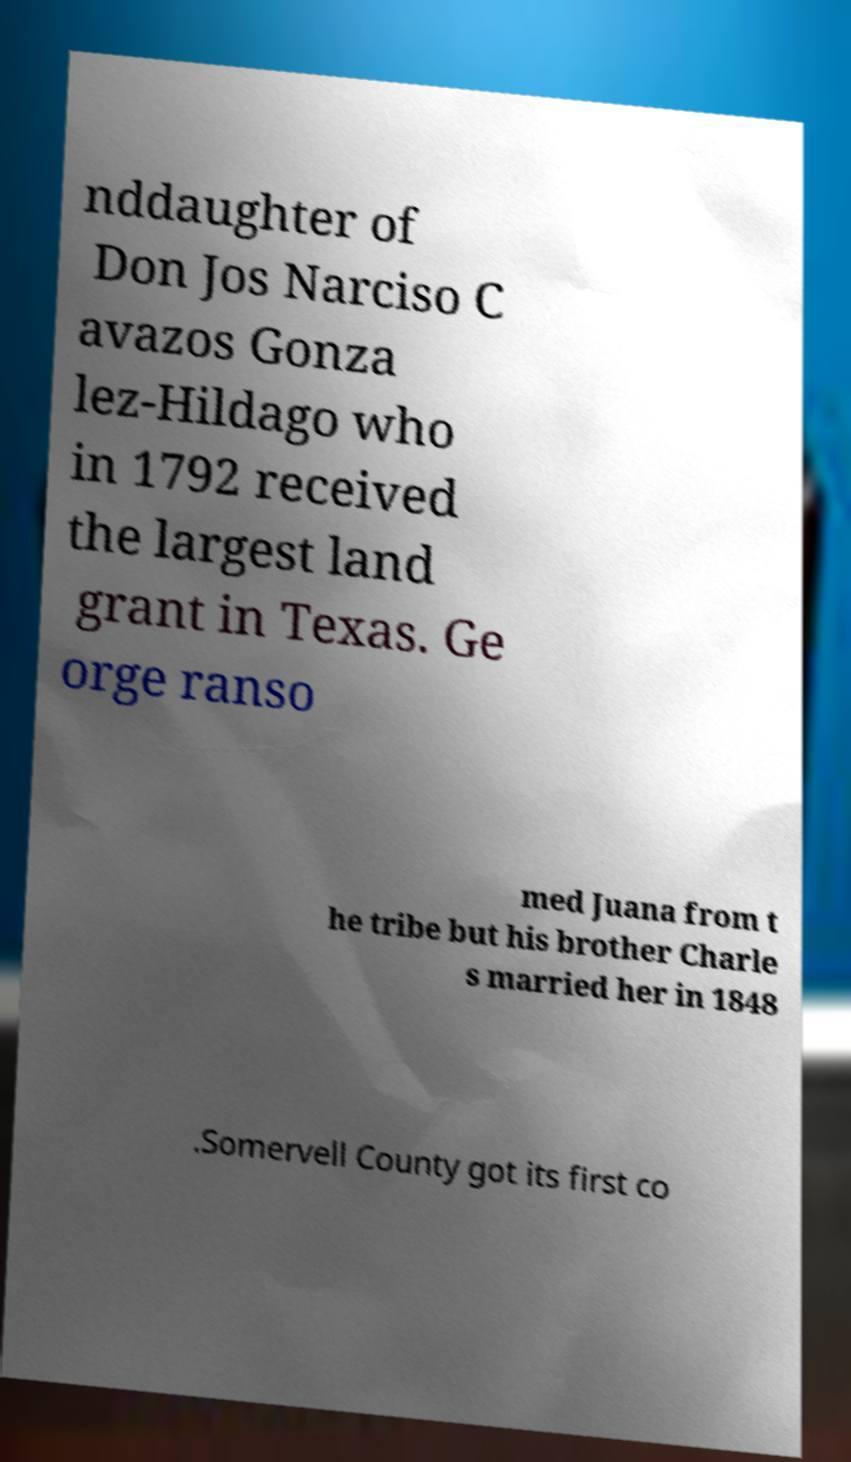I need the written content from this picture converted into text. Can you do that? nddaughter of Don Jos Narciso C avazos Gonza lez-Hildago who in 1792 received the largest land grant in Texas. Ge orge ranso med Juana from t he tribe but his brother Charle s married her in 1848 .Somervell County got its first co 